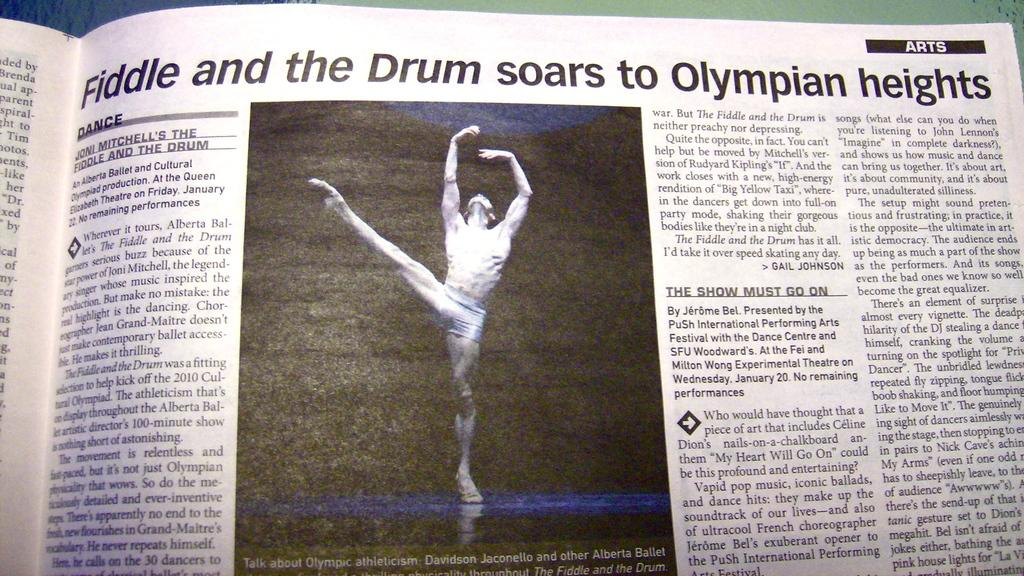Provide a one-sentence caption for the provided image. A newspaper article in the arts section with a picture of a male ballet dancer on it. 